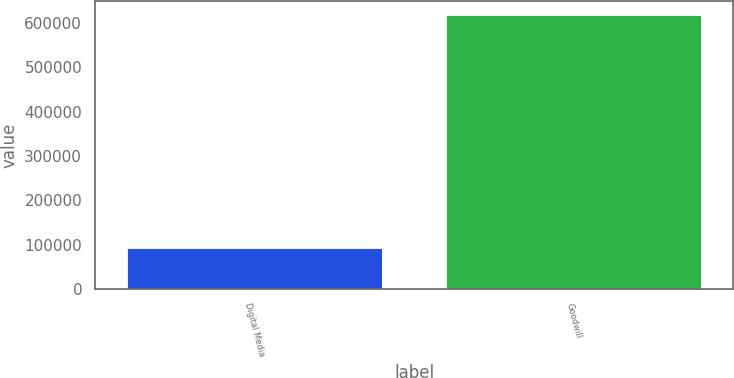Convert chart to OTSL. <chart><loc_0><loc_0><loc_500><loc_500><bar_chart><fcel>Digital Media<fcel>Goodwill<nl><fcel>91355<fcel>618094<nl></chart> 